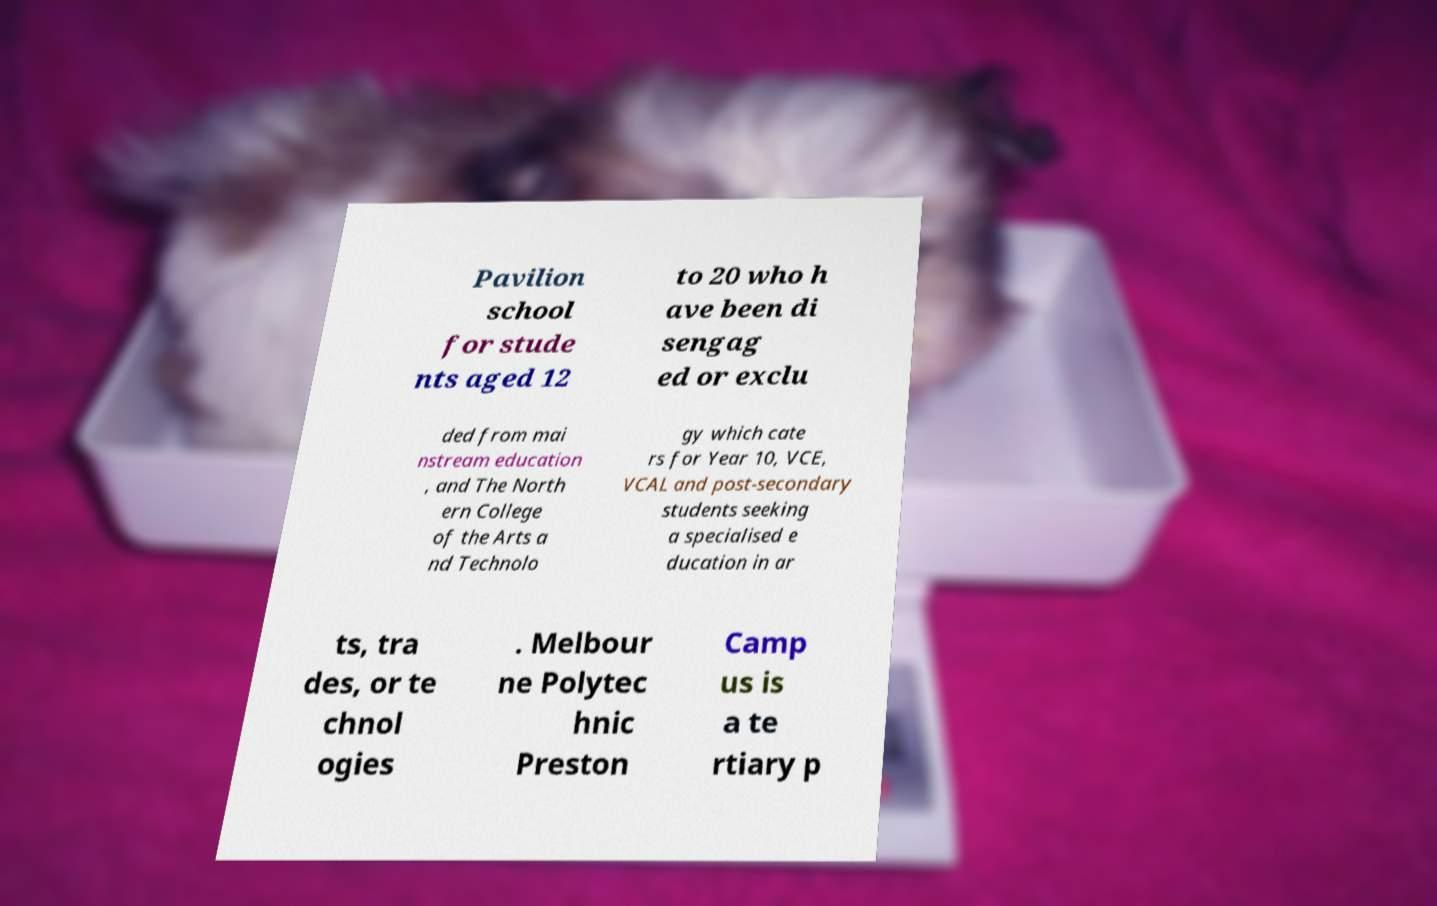What messages or text are displayed in this image? I need them in a readable, typed format. Pavilion school for stude nts aged 12 to 20 who h ave been di sengag ed or exclu ded from mai nstream education , and The North ern College of the Arts a nd Technolo gy which cate rs for Year 10, VCE, VCAL and post-secondary students seeking a specialised e ducation in ar ts, tra des, or te chnol ogies . Melbour ne Polytec hnic Preston Camp us is a te rtiary p 